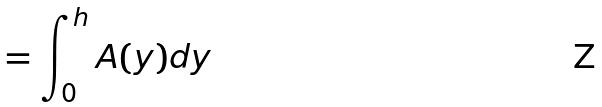Convert formula to latex. <formula><loc_0><loc_0><loc_500><loc_500>= \int _ { 0 } ^ { h } A ( y ) d y</formula> 